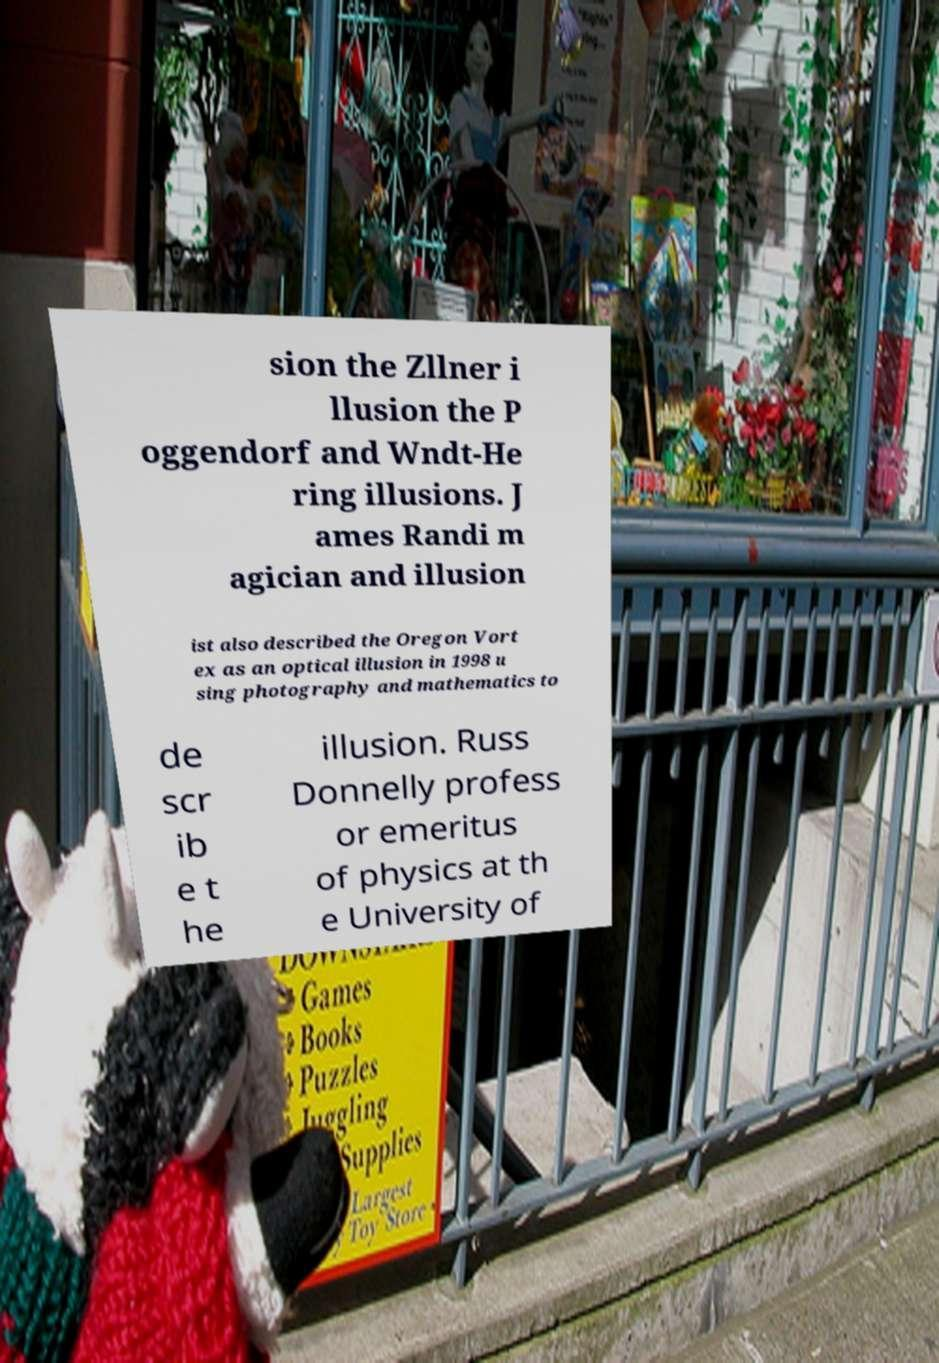Can you accurately transcribe the text from the provided image for me? sion the Zllner i llusion the P oggendorf and Wndt-He ring illusions. J ames Randi m agician and illusion ist also described the Oregon Vort ex as an optical illusion in 1998 u sing photography and mathematics to de scr ib e t he illusion. Russ Donnelly profess or emeritus of physics at th e University of 